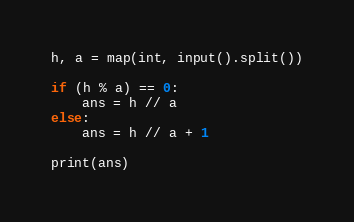<code> <loc_0><loc_0><loc_500><loc_500><_Python_>h, a = map(int, input().split())

if (h % a) == 0:
    ans = h // a
else:
    ans = h // a + 1

print(ans)</code> 